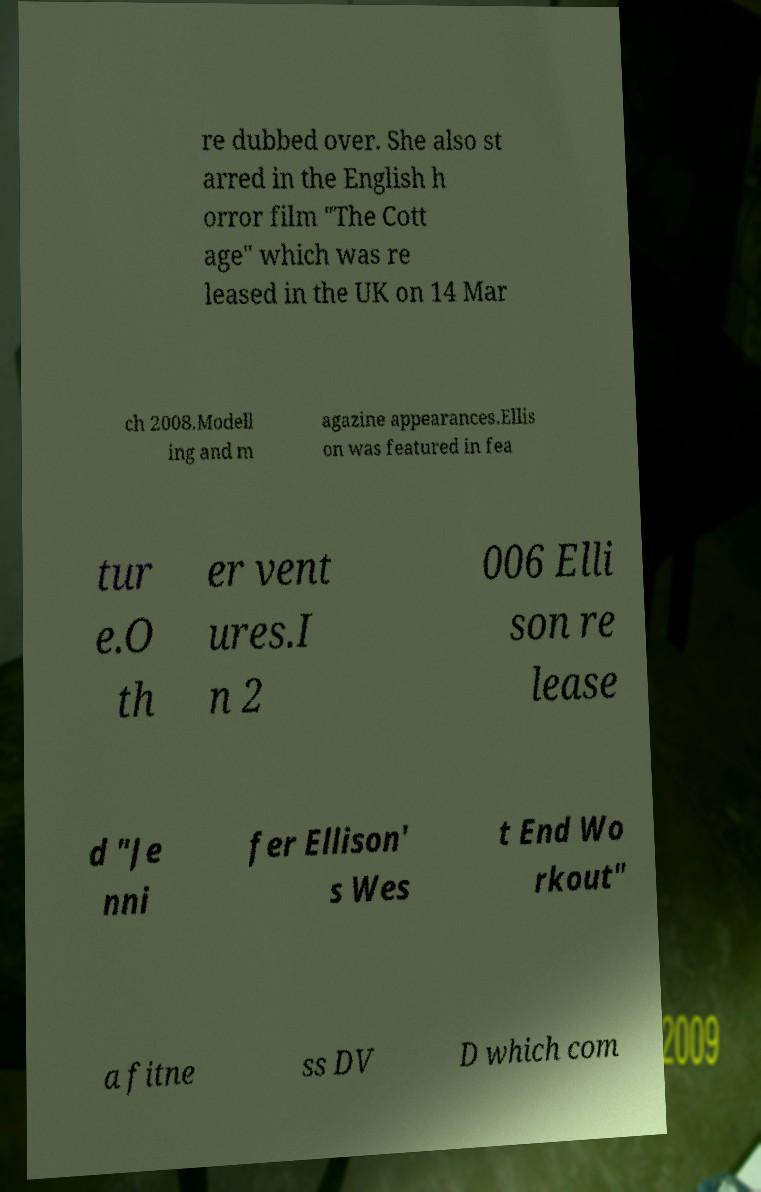Can you accurately transcribe the text from the provided image for me? re dubbed over. She also st arred in the English h orror film "The Cott age" which was re leased in the UK on 14 Mar ch 2008.Modell ing and m agazine appearances.Ellis on was featured in fea tur e.O th er vent ures.I n 2 006 Elli son re lease d "Je nni fer Ellison' s Wes t End Wo rkout" a fitne ss DV D which com 